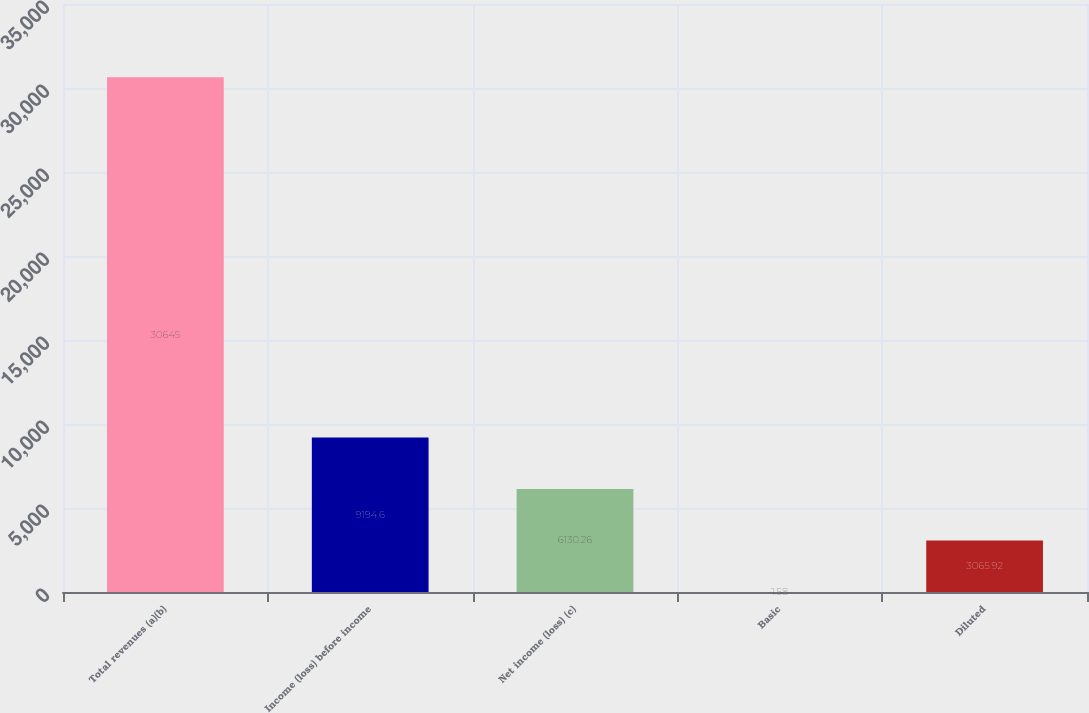<chart> <loc_0><loc_0><loc_500><loc_500><bar_chart><fcel>Total revenues (a)(b)<fcel>Income (loss) before income<fcel>Net income (loss) (c)<fcel>Basic<fcel>Diluted<nl><fcel>30645<fcel>9194.6<fcel>6130.26<fcel>1.58<fcel>3065.92<nl></chart> 